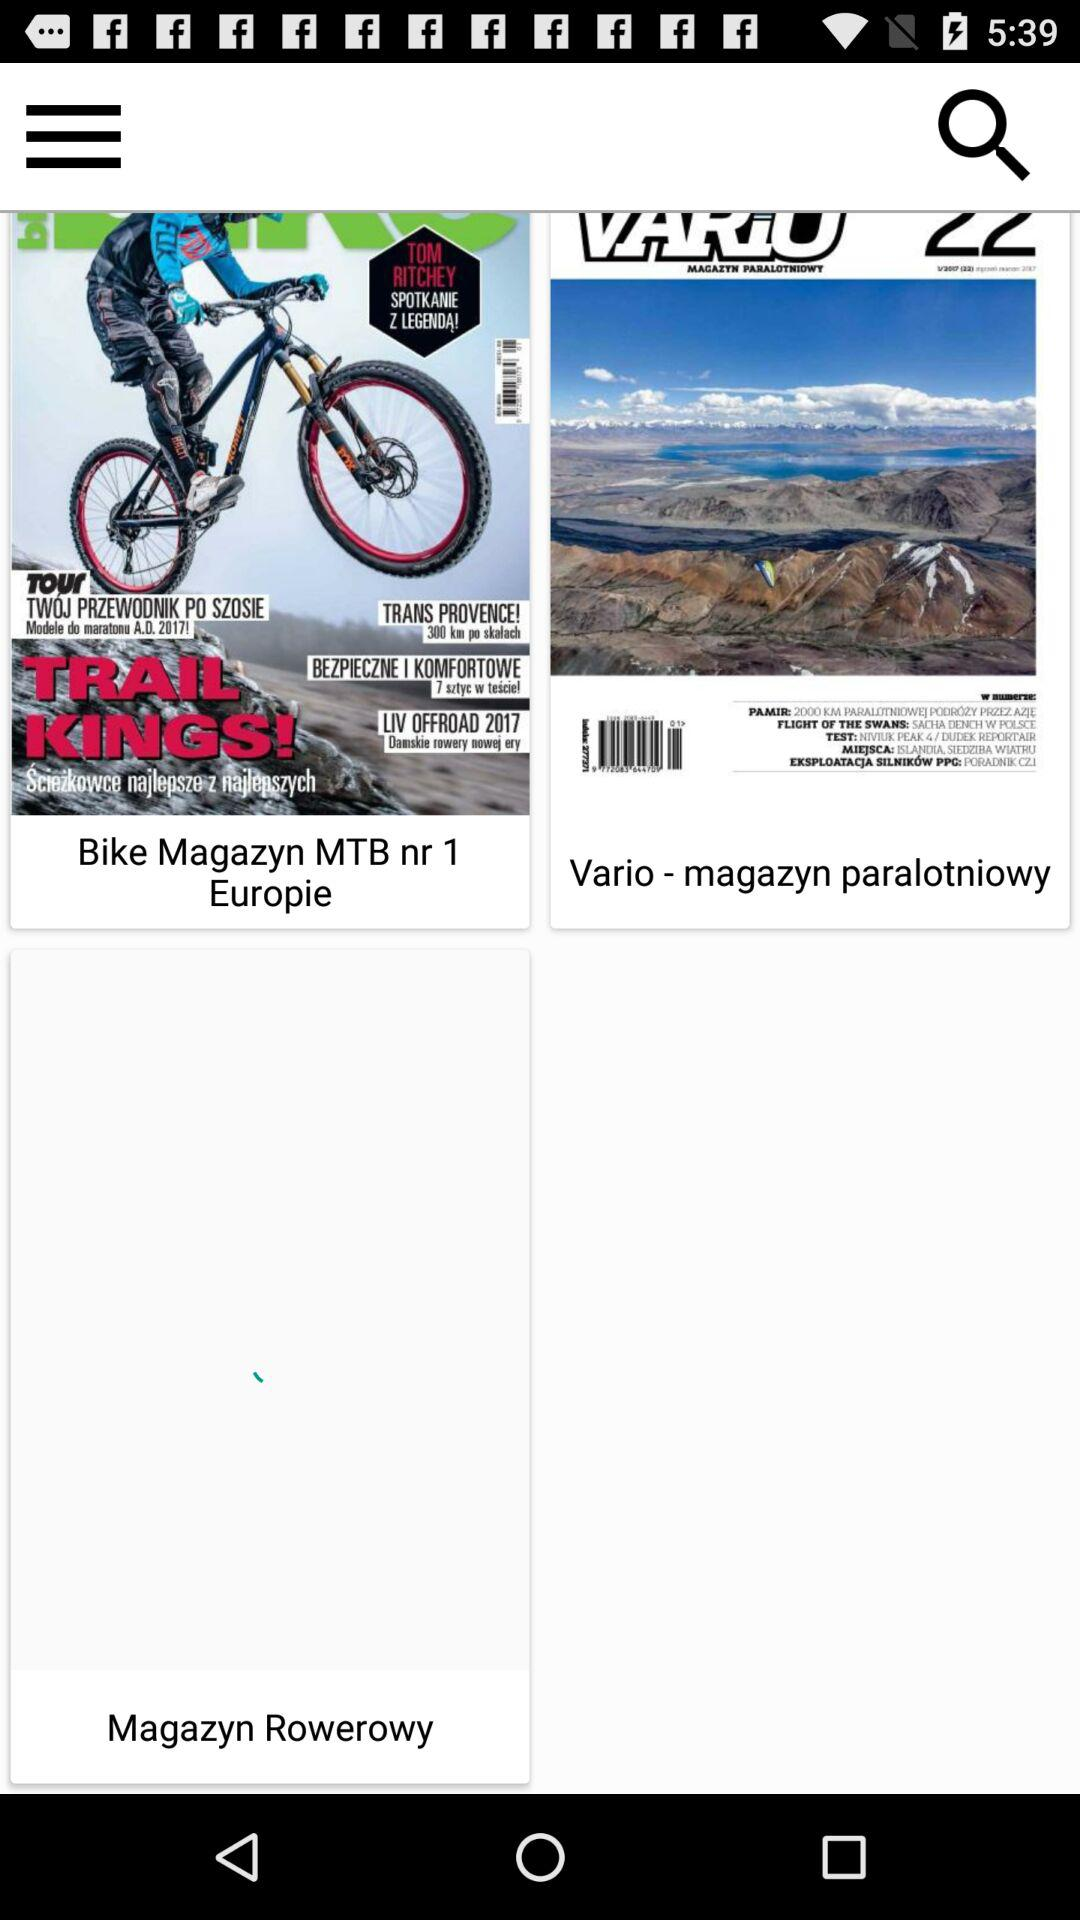How many magazine covers are there?
Answer the question using a single word or phrase. 3 